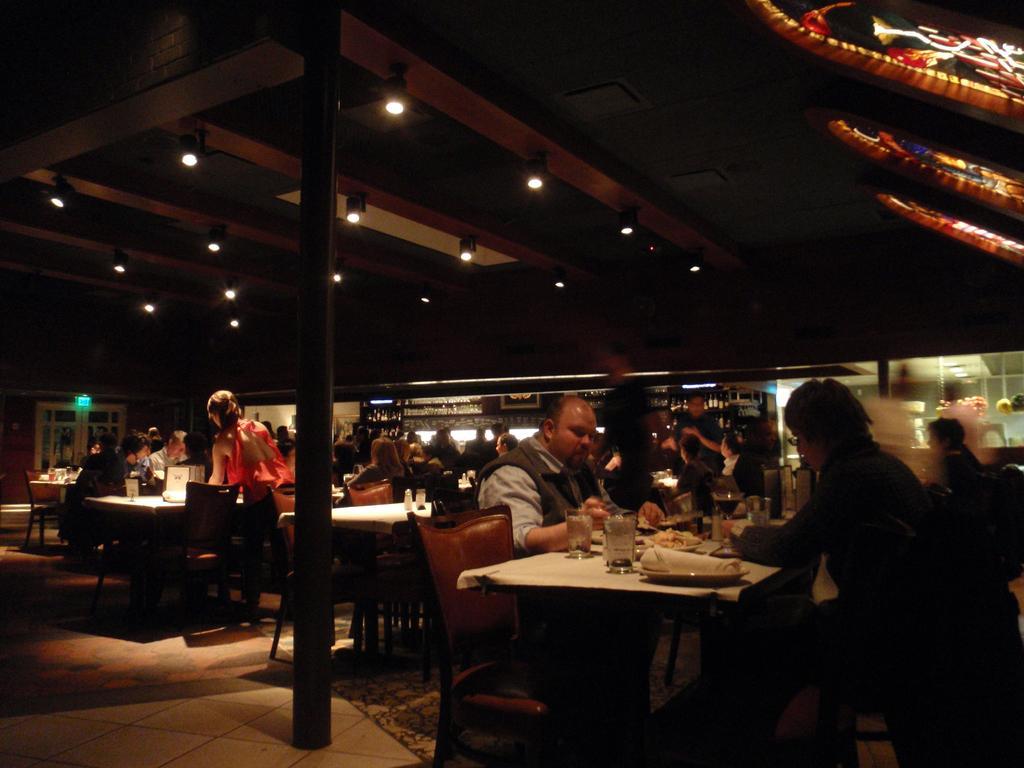Can you describe this image briefly? A picture of a restaurant. Persons are sitting on chairs. In-front of them there are tables, on table there is a cloth, glasses and plate. On top there are lights. This is pole.. 